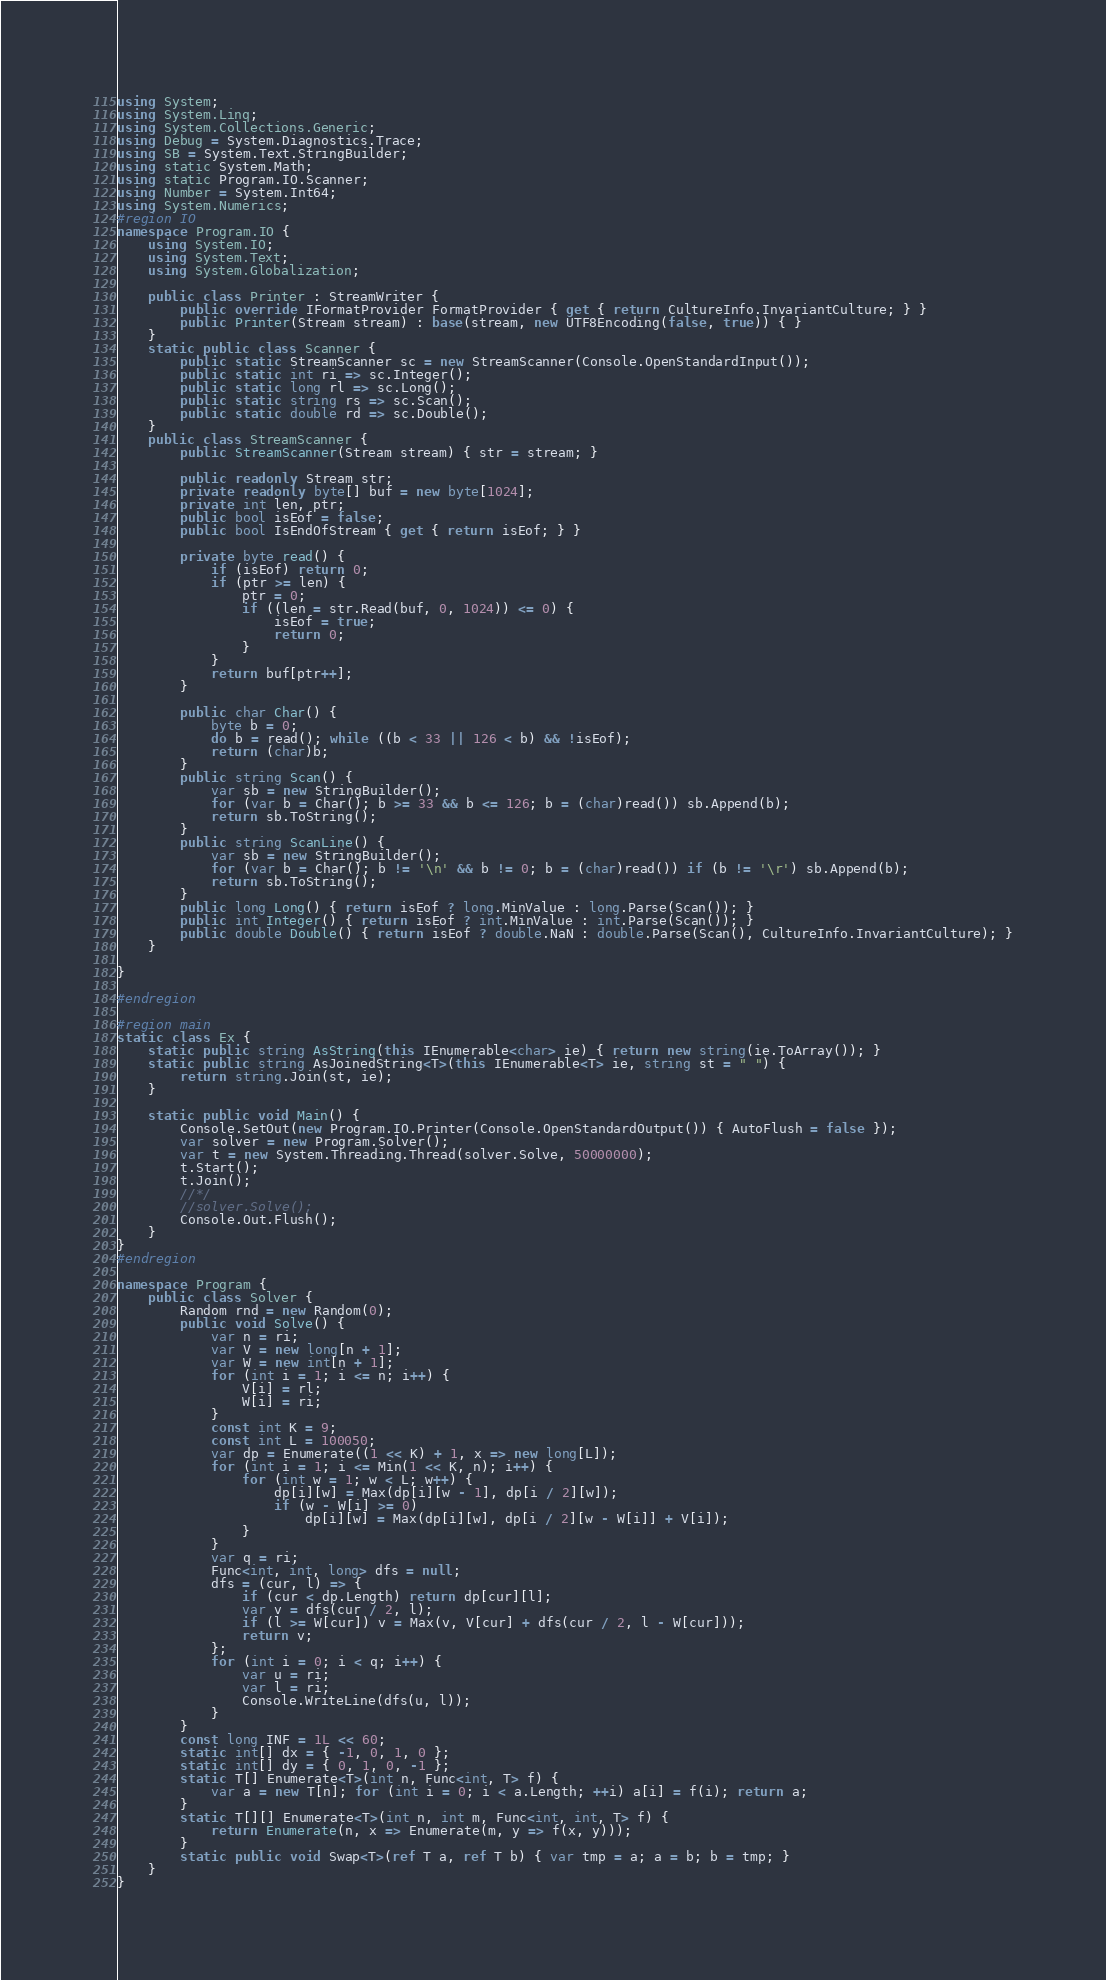Convert code to text. <code><loc_0><loc_0><loc_500><loc_500><_C#_>using System;
using System.Linq;
using System.Collections.Generic;
using Debug = System.Diagnostics.Trace;
using SB = System.Text.StringBuilder;
using static System.Math;
using static Program.IO.Scanner;
using Number = System.Int64;
using System.Numerics;
#region IO
namespace Program.IO {
	using System.IO;
	using System.Text;
	using System.Globalization;

	public class Printer : StreamWriter {
		public override IFormatProvider FormatProvider { get { return CultureInfo.InvariantCulture; } }
		public Printer(Stream stream) : base(stream, new UTF8Encoding(false, true)) { }
	}
	static public class Scanner {
		public static StreamScanner sc = new StreamScanner(Console.OpenStandardInput());
		public static int ri => sc.Integer();
		public static long rl => sc.Long();
		public static string rs => sc.Scan();
		public static double rd => sc.Double();
	}
	public class StreamScanner {
		public StreamScanner(Stream stream) { str = stream; }

		public readonly Stream str;
		private readonly byte[] buf = new byte[1024];
		private int len, ptr;
		public bool isEof = false;
		public bool IsEndOfStream { get { return isEof; } }

		private byte read() {
			if (isEof) return 0;
			if (ptr >= len) {
				ptr = 0;
				if ((len = str.Read(buf, 0, 1024)) <= 0) {
					isEof = true;
					return 0;
				}
			}
			return buf[ptr++];
		}

		public char Char() {
			byte b = 0;
			do b = read(); while ((b < 33 || 126 < b) && !isEof);
			return (char)b;
		}
		public string Scan() {
			var sb = new StringBuilder();
			for (var b = Char(); b >= 33 && b <= 126; b = (char)read()) sb.Append(b);
			return sb.ToString();
		}
		public string ScanLine() {
			var sb = new StringBuilder();
			for (var b = Char(); b != '\n' && b != 0; b = (char)read()) if (b != '\r') sb.Append(b);
			return sb.ToString();
		}
		public long Long() { return isEof ? long.MinValue : long.Parse(Scan()); }
		public int Integer() { return isEof ? int.MinValue : int.Parse(Scan()); }
		public double Double() { return isEof ? double.NaN : double.Parse(Scan(), CultureInfo.InvariantCulture); }
	}

}

#endregion

#region main
static class Ex {
	static public string AsString(this IEnumerable<char> ie) { return new string(ie.ToArray()); }
	static public string AsJoinedString<T>(this IEnumerable<T> ie, string st = " ") {
		return string.Join(st, ie);
	}

	static public void Main() {
		Console.SetOut(new Program.IO.Printer(Console.OpenStandardOutput()) { AutoFlush = false });
		var solver = new Program.Solver();
		var t = new System.Threading.Thread(solver.Solve, 50000000);
		t.Start();
		t.Join();
		//*/
		//solver.Solve();
		Console.Out.Flush();
	}
}
#endregion

namespace Program {
	public class Solver {
		Random rnd = new Random(0);
		public void Solve() {
			var n = ri;
			var V = new long[n + 1];
			var W = new int[n + 1];
			for (int i = 1; i <= n; i++) {
				V[i] = rl;
				W[i] = ri;
			}
			const int K = 9;
			const int L = 100050;
			var dp = Enumerate((1 << K) + 1, x => new long[L]);
			for (int i = 1; i <= Min(1 << K, n); i++) {
				for (int w = 1; w < L; w++) {
					dp[i][w] = Max(dp[i][w - 1], dp[i / 2][w]);
					if (w - W[i] >= 0)
						dp[i][w] = Max(dp[i][w], dp[i / 2][w - W[i]] + V[i]);
				}
			}
			var q = ri;
			Func<int, int, long> dfs = null;
			dfs = (cur, l) => {
				if (cur < dp.Length) return dp[cur][l];
				var v = dfs(cur / 2, l);
				if (l >= W[cur]) v = Max(v, V[cur] + dfs(cur / 2, l - W[cur]));
				return v;
			};
			for (int i = 0; i < q; i++) {
				var u = ri;
				var l = ri;
				Console.WriteLine(dfs(u, l));
			}
		}
		const long INF = 1L << 60;
		static int[] dx = { -1, 0, 1, 0 };
		static int[] dy = { 0, 1, 0, -1 };
		static T[] Enumerate<T>(int n, Func<int, T> f) {
			var a = new T[n]; for (int i = 0; i < a.Length; ++i) a[i] = f(i); return a;
		}
		static T[][] Enumerate<T>(int n, int m, Func<int, int, T> f) {
			return Enumerate(n, x => Enumerate(m, y => f(x, y)));
		}
		static public void Swap<T>(ref T a, ref T b) { var tmp = a; a = b; b = tmp; }
	}
}
</code> 